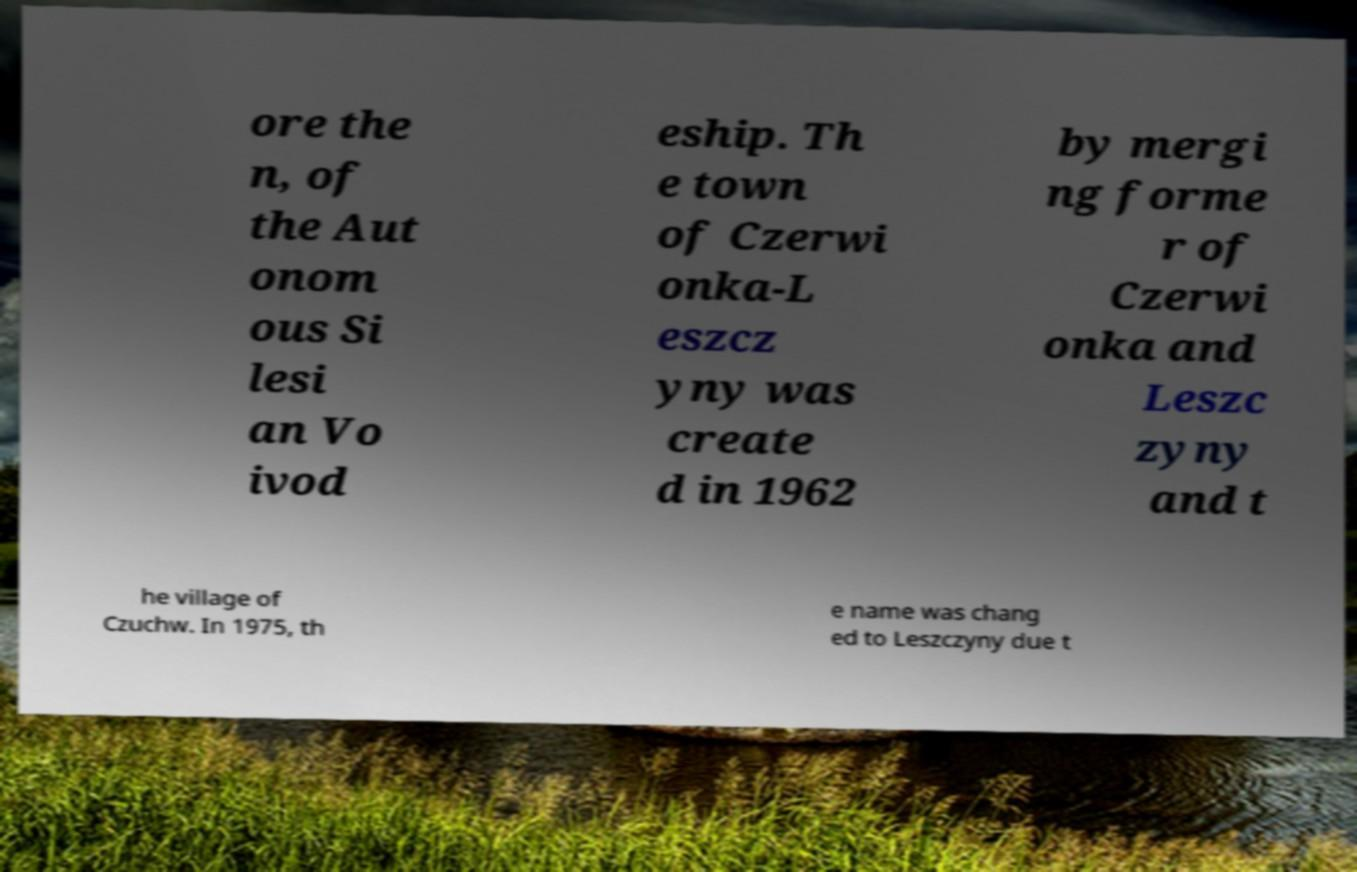Can you read and provide the text displayed in the image?This photo seems to have some interesting text. Can you extract and type it out for me? ore the n, of the Aut onom ous Si lesi an Vo ivod eship. Th e town of Czerwi onka-L eszcz yny was create d in 1962 by mergi ng forme r of Czerwi onka and Leszc zyny and t he village of Czuchw. In 1975, th e name was chang ed to Leszczyny due t 